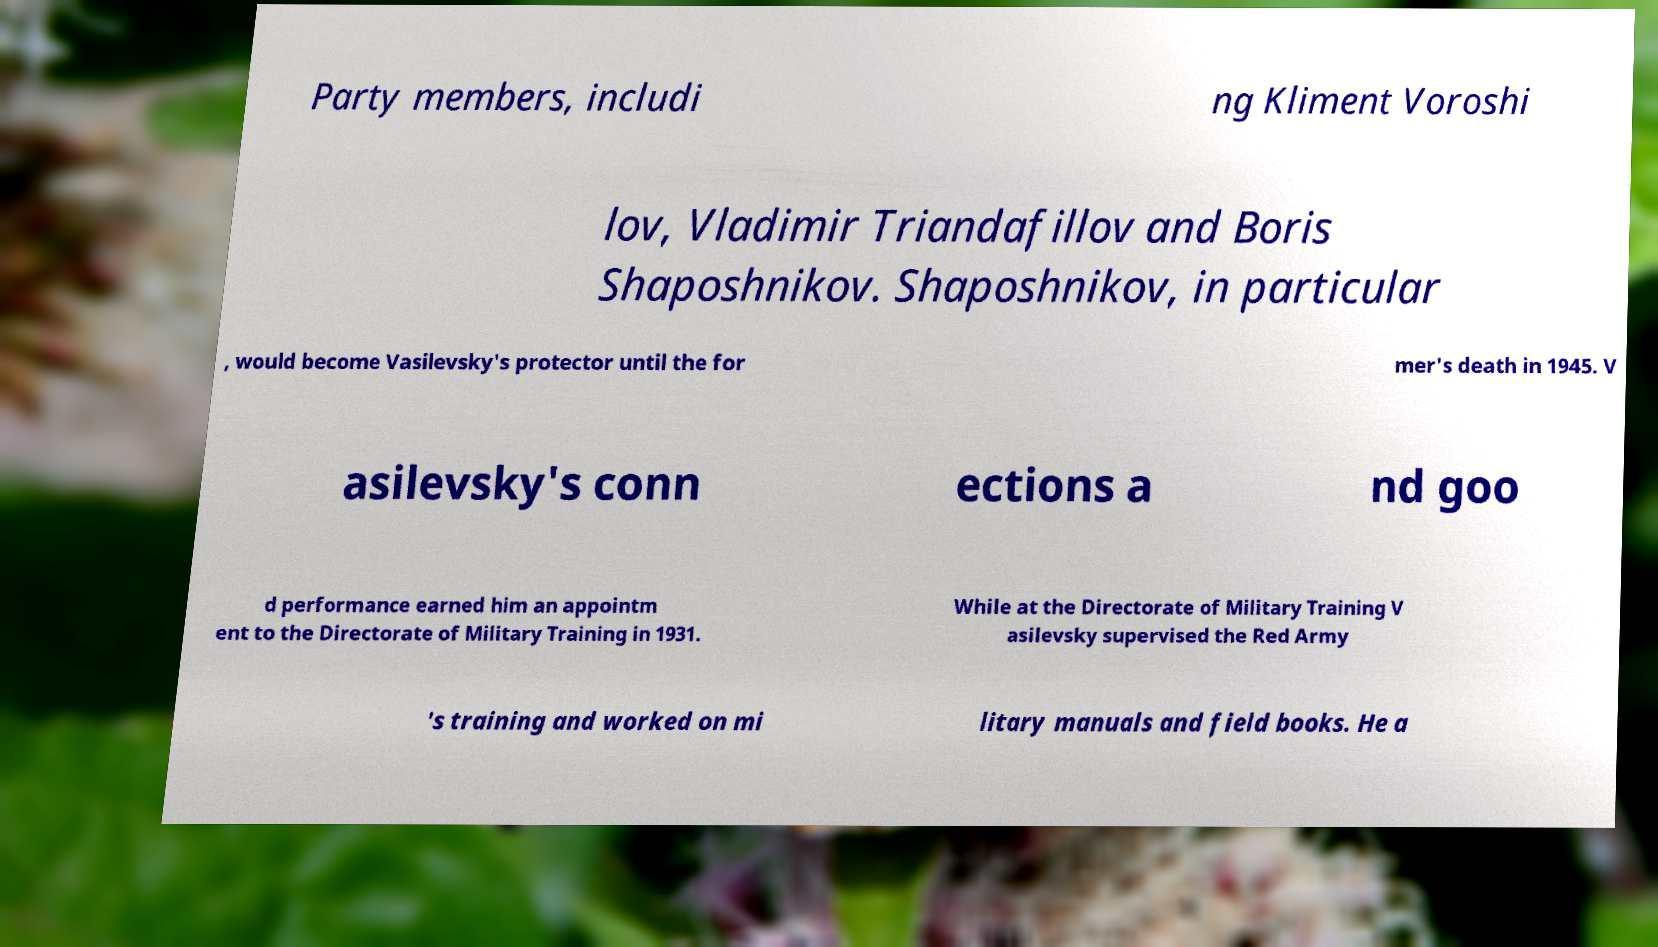I need the written content from this picture converted into text. Can you do that? Party members, includi ng Kliment Voroshi lov, Vladimir Triandafillov and Boris Shaposhnikov. Shaposhnikov, in particular , would become Vasilevsky's protector until the for mer's death in 1945. V asilevsky's conn ections a nd goo d performance earned him an appointm ent to the Directorate of Military Training in 1931. While at the Directorate of Military Training V asilevsky supervised the Red Army 's training and worked on mi litary manuals and field books. He a 